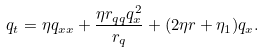<formula> <loc_0><loc_0><loc_500><loc_500>q _ { t } = \eta q _ { x x } + \frac { \eta r _ { q q } q _ { x } ^ { 2 } } { r _ { q } } + ( 2 \eta r + \eta _ { 1 } ) q _ { x } .</formula> 